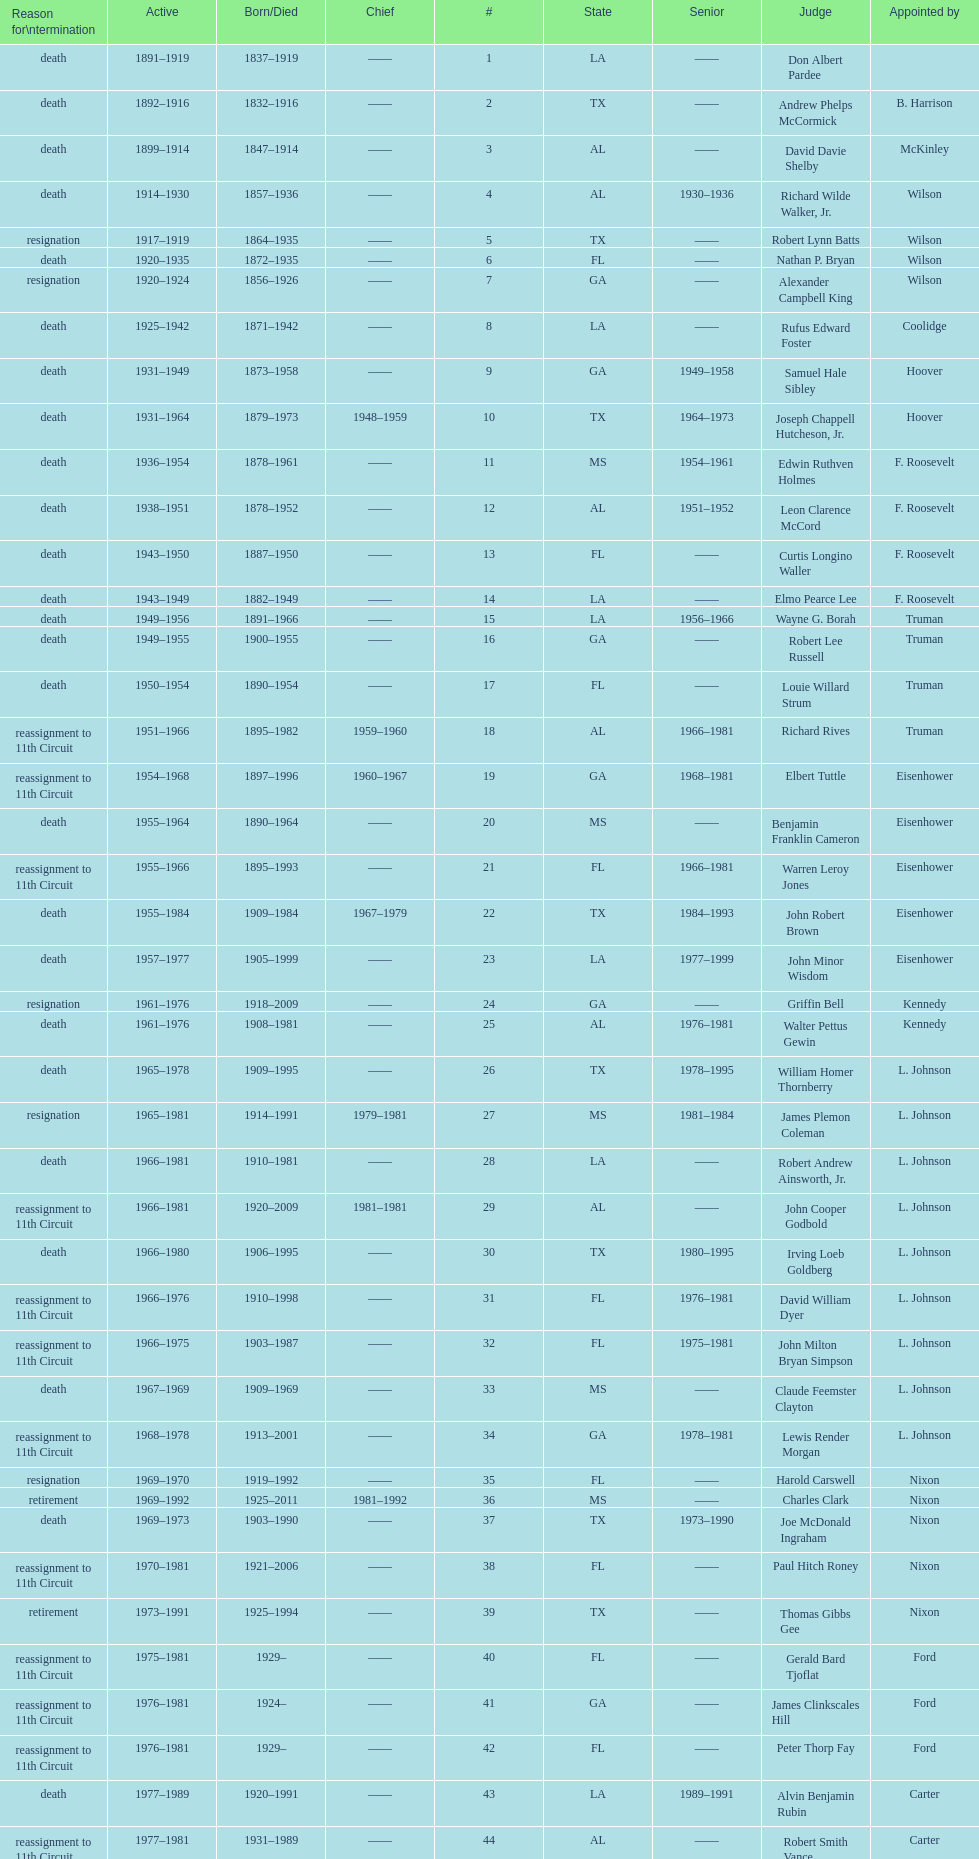Parse the full table. {'header': ['Reason for\\ntermination', 'Active', 'Born/Died', 'Chief', '#', 'State', 'Senior', 'Judge', 'Appointed by'], 'rows': [['death', '1891–1919', '1837–1919', '——', '1', 'LA', '——', 'Don Albert Pardee', ''], ['death', '1892–1916', '1832–1916', '——', '2', 'TX', '——', 'Andrew Phelps McCormick', 'B. Harrison'], ['death', '1899–1914', '1847–1914', '——', '3', 'AL', '——', 'David Davie Shelby', 'McKinley'], ['death', '1914–1930', '1857–1936', '——', '4', 'AL', '1930–1936', 'Richard Wilde Walker, Jr.', 'Wilson'], ['resignation', '1917–1919', '1864–1935', '——', '5', 'TX', '——', 'Robert Lynn Batts', 'Wilson'], ['death', '1920–1935', '1872–1935', '——', '6', 'FL', '——', 'Nathan P. Bryan', 'Wilson'], ['resignation', '1920–1924', '1856–1926', '——', '7', 'GA', '——', 'Alexander Campbell King', 'Wilson'], ['death', '1925–1942', '1871–1942', '——', '8', 'LA', '——', 'Rufus Edward Foster', 'Coolidge'], ['death', '1931–1949', '1873–1958', '——', '9', 'GA', '1949–1958', 'Samuel Hale Sibley', 'Hoover'], ['death', '1931–1964', '1879–1973', '1948–1959', '10', 'TX', '1964–1973', 'Joseph Chappell Hutcheson, Jr.', 'Hoover'], ['death', '1936–1954', '1878–1961', '——', '11', 'MS', '1954–1961', 'Edwin Ruthven Holmes', 'F. Roosevelt'], ['death', '1938–1951', '1878–1952', '——', '12', 'AL', '1951–1952', 'Leon Clarence McCord', 'F. Roosevelt'], ['death', '1943–1950', '1887–1950', '——', '13', 'FL', '——', 'Curtis Longino Waller', 'F. Roosevelt'], ['death', '1943–1949', '1882–1949', '——', '14', 'LA', '——', 'Elmo Pearce Lee', 'F. Roosevelt'], ['death', '1949–1956', '1891–1966', '——', '15', 'LA', '1956–1966', 'Wayne G. Borah', 'Truman'], ['death', '1949–1955', '1900–1955', '——', '16', 'GA', '——', 'Robert Lee Russell', 'Truman'], ['death', '1950–1954', '1890–1954', '——', '17', 'FL', '——', 'Louie Willard Strum', 'Truman'], ['reassignment to 11th Circuit', '1951–1966', '1895–1982', '1959–1960', '18', 'AL', '1966–1981', 'Richard Rives', 'Truman'], ['reassignment to 11th Circuit', '1954–1968', '1897–1996', '1960–1967', '19', 'GA', '1968–1981', 'Elbert Tuttle', 'Eisenhower'], ['death', '1955–1964', '1890–1964', '——', '20', 'MS', '——', 'Benjamin Franklin Cameron', 'Eisenhower'], ['reassignment to 11th Circuit', '1955–1966', '1895–1993', '——', '21', 'FL', '1966–1981', 'Warren Leroy Jones', 'Eisenhower'], ['death', '1955–1984', '1909–1984', '1967–1979', '22', 'TX', '1984–1993', 'John Robert Brown', 'Eisenhower'], ['death', '1957–1977', '1905–1999', '——', '23', 'LA', '1977–1999', 'John Minor Wisdom', 'Eisenhower'], ['resignation', '1961–1976', '1918–2009', '——', '24', 'GA', '——', 'Griffin Bell', 'Kennedy'], ['death', '1961–1976', '1908–1981', '——', '25', 'AL', '1976–1981', 'Walter Pettus Gewin', 'Kennedy'], ['death', '1965–1978', '1909–1995', '——', '26', 'TX', '1978–1995', 'William Homer Thornberry', 'L. Johnson'], ['resignation', '1965–1981', '1914–1991', '1979–1981', '27', 'MS', '1981–1984', 'James Plemon Coleman', 'L. Johnson'], ['death', '1966–1981', '1910–1981', '——', '28', 'LA', '——', 'Robert Andrew Ainsworth, Jr.', 'L. Johnson'], ['reassignment to 11th Circuit', '1966–1981', '1920–2009', '1981–1981', '29', 'AL', '——', 'John Cooper Godbold', 'L. Johnson'], ['death', '1966–1980', '1906–1995', '——', '30', 'TX', '1980–1995', 'Irving Loeb Goldberg', 'L. Johnson'], ['reassignment to 11th Circuit', '1966–1976', '1910–1998', '——', '31', 'FL', '1976–1981', 'David William Dyer', 'L. Johnson'], ['reassignment to 11th Circuit', '1966–1975', '1903–1987', '——', '32', 'FL', '1975–1981', 'John Milton Bryan Simpson', 'L. Johnson'], ['death', '1967–1969', '1909–1969', '——', '33', 'MS', '——', 'Claude Feemster Clayton', 'L. Johnson'], ['reassignment to 11th Circuit', '1968–1978', '1913–2001', '——', '34', 'GA', '1978–1981', 'Lewis Render Morgan', 'L. Johnson'], ['resignation', '1969–1970', '1919–1992', '——', '35', 'FL', '——', 'Harold Carswell', 'Nixon'], ['retirement', '1969–1992', '1925–2011', '1981–1992', '36', 'MS', '——', 'Charles Clark', 'Nixon'], ['death', '1969–1973', '1903–1990', '——', '37', 'TX', '1973–1990', 'Joe McDonald Ingraham', 'Nixon'], ['reassignment to 11th Circuit', '1970–1981', '1921–2006', '——', '38', 'FL', '——', 'Paul Hitch Roney', 'Nixon'], ['retirement', '1973–1991', '1925–1994', '——', '39', 'TX', '——', 'Thomas Gibbs Gee', 'Nixon'], ['reassignment to 11th Circuit', '1975–1981', '1929–', '——', '40', 'FL', '——', 'Gerald Bard Tjoflat', 'Ford'], ['reassignment to 11th Circuit', '1976–1981', '1924–', '——', '41', 'GA', '——', 'James Clinkscales Hill', 'Ford'], ['reassignment to 11th Circuit', '1976–1981', '1929–', '——', '42', 'FL', '——', 'Peter Thorp Fay', 'Ford'], ['death', '1977–1989', '1920–1991', '——', '43', 'LA', '1989–1991', 'Alvin Benjamin Rubin', 'Carter'], ['reassignment to 11th Circuit', '1977–1981', '1931–1989', '——', '44', 'AL', '——', 'Robert Smith Vance', 'Carter'], ['reassignment to 11th Circuit', '1979–1981', '1920–', '——', '45', 'GA', '——', 'Phyllis A. Kravitch', 'Carter'], ['reassignment to 11th Circuit', '1979–1981', '1918–1999', '——', '46', 'AL', '——', 'Frank Minis Johnson', 'Carter'], ['reassignment to 11th Circuit', '1979–1981', '1936–', '——', '47', 'GA', '——', 'R. Lanier Anderson III', 'Carter'], ['death', '1979–1982', '1915–2004', '——', '48', 'TX', '1982–2004', 'Reynaldo Guerra Garza', 'Carter'], ['reassignment to 11th Circuit', '1979–1981', '1932–', '——', '49', 'FL', '——', 'Joseph Woodrow Hatchett', 'Carter'], ['reassignment to 11th Circuit', '1979–1981', '1920–1999', '——', '50', 'GA', '——', 'Albert John Henderson', 'Carter'], ['death', '1979–1999', '1932–2002', '1992–1999', '52', 'LA', '1999–2002', 'Henry Anthony Politz', 'Carter'], ['death', '1979–1991', '1920–2002', '——', '54', 'TX', '1991–2002', 'Samuel D. Johnson, Jr.', 'Carter'], ['death', '1979–1986', '1920–1986', '——', '55', 'LA', '——', 'Albert Tate, Jr.', 'Carter'], ['reassignment to 11th Circuit', '1979–1981', '1920–2005', '——', '56', 'GA', '——', 'Thomas Alonzo Clark', 'Carter'], ['death', '1980–1990', '1916–1993', '——', '57', 'TX', '1990–1993', 'Jerre Stockton Williams', 'Carter'], ['death', '1981–1997', '1931–2011', '——', '58', 'TX', '1997–2011', 'William Lockhart Garwood', 'Reagan'], ['death', '1984–1987', '1928–1987', '——', '62', 'TX', '——', 'Robert Madden Hill', 'Reagan'], ['retirement', '1988–1999', '1933-', '——', '65', 'LA', '1999–2011', 'John Malcolm Duhé, Jr.', 'Reagan'], ['retirement', '1994–2002', '1937–', '——', '72', 'TX', '——', 'Robert Manley Parker', 'Clinton'], ['retirement', '2004–2004', '1937–', '——', '76', 'MS', '——', 'Charles W. Pickering', 'G.W. Bush']]} Who was the first judge from florida to serve the position? Nathan P. Bryan. 